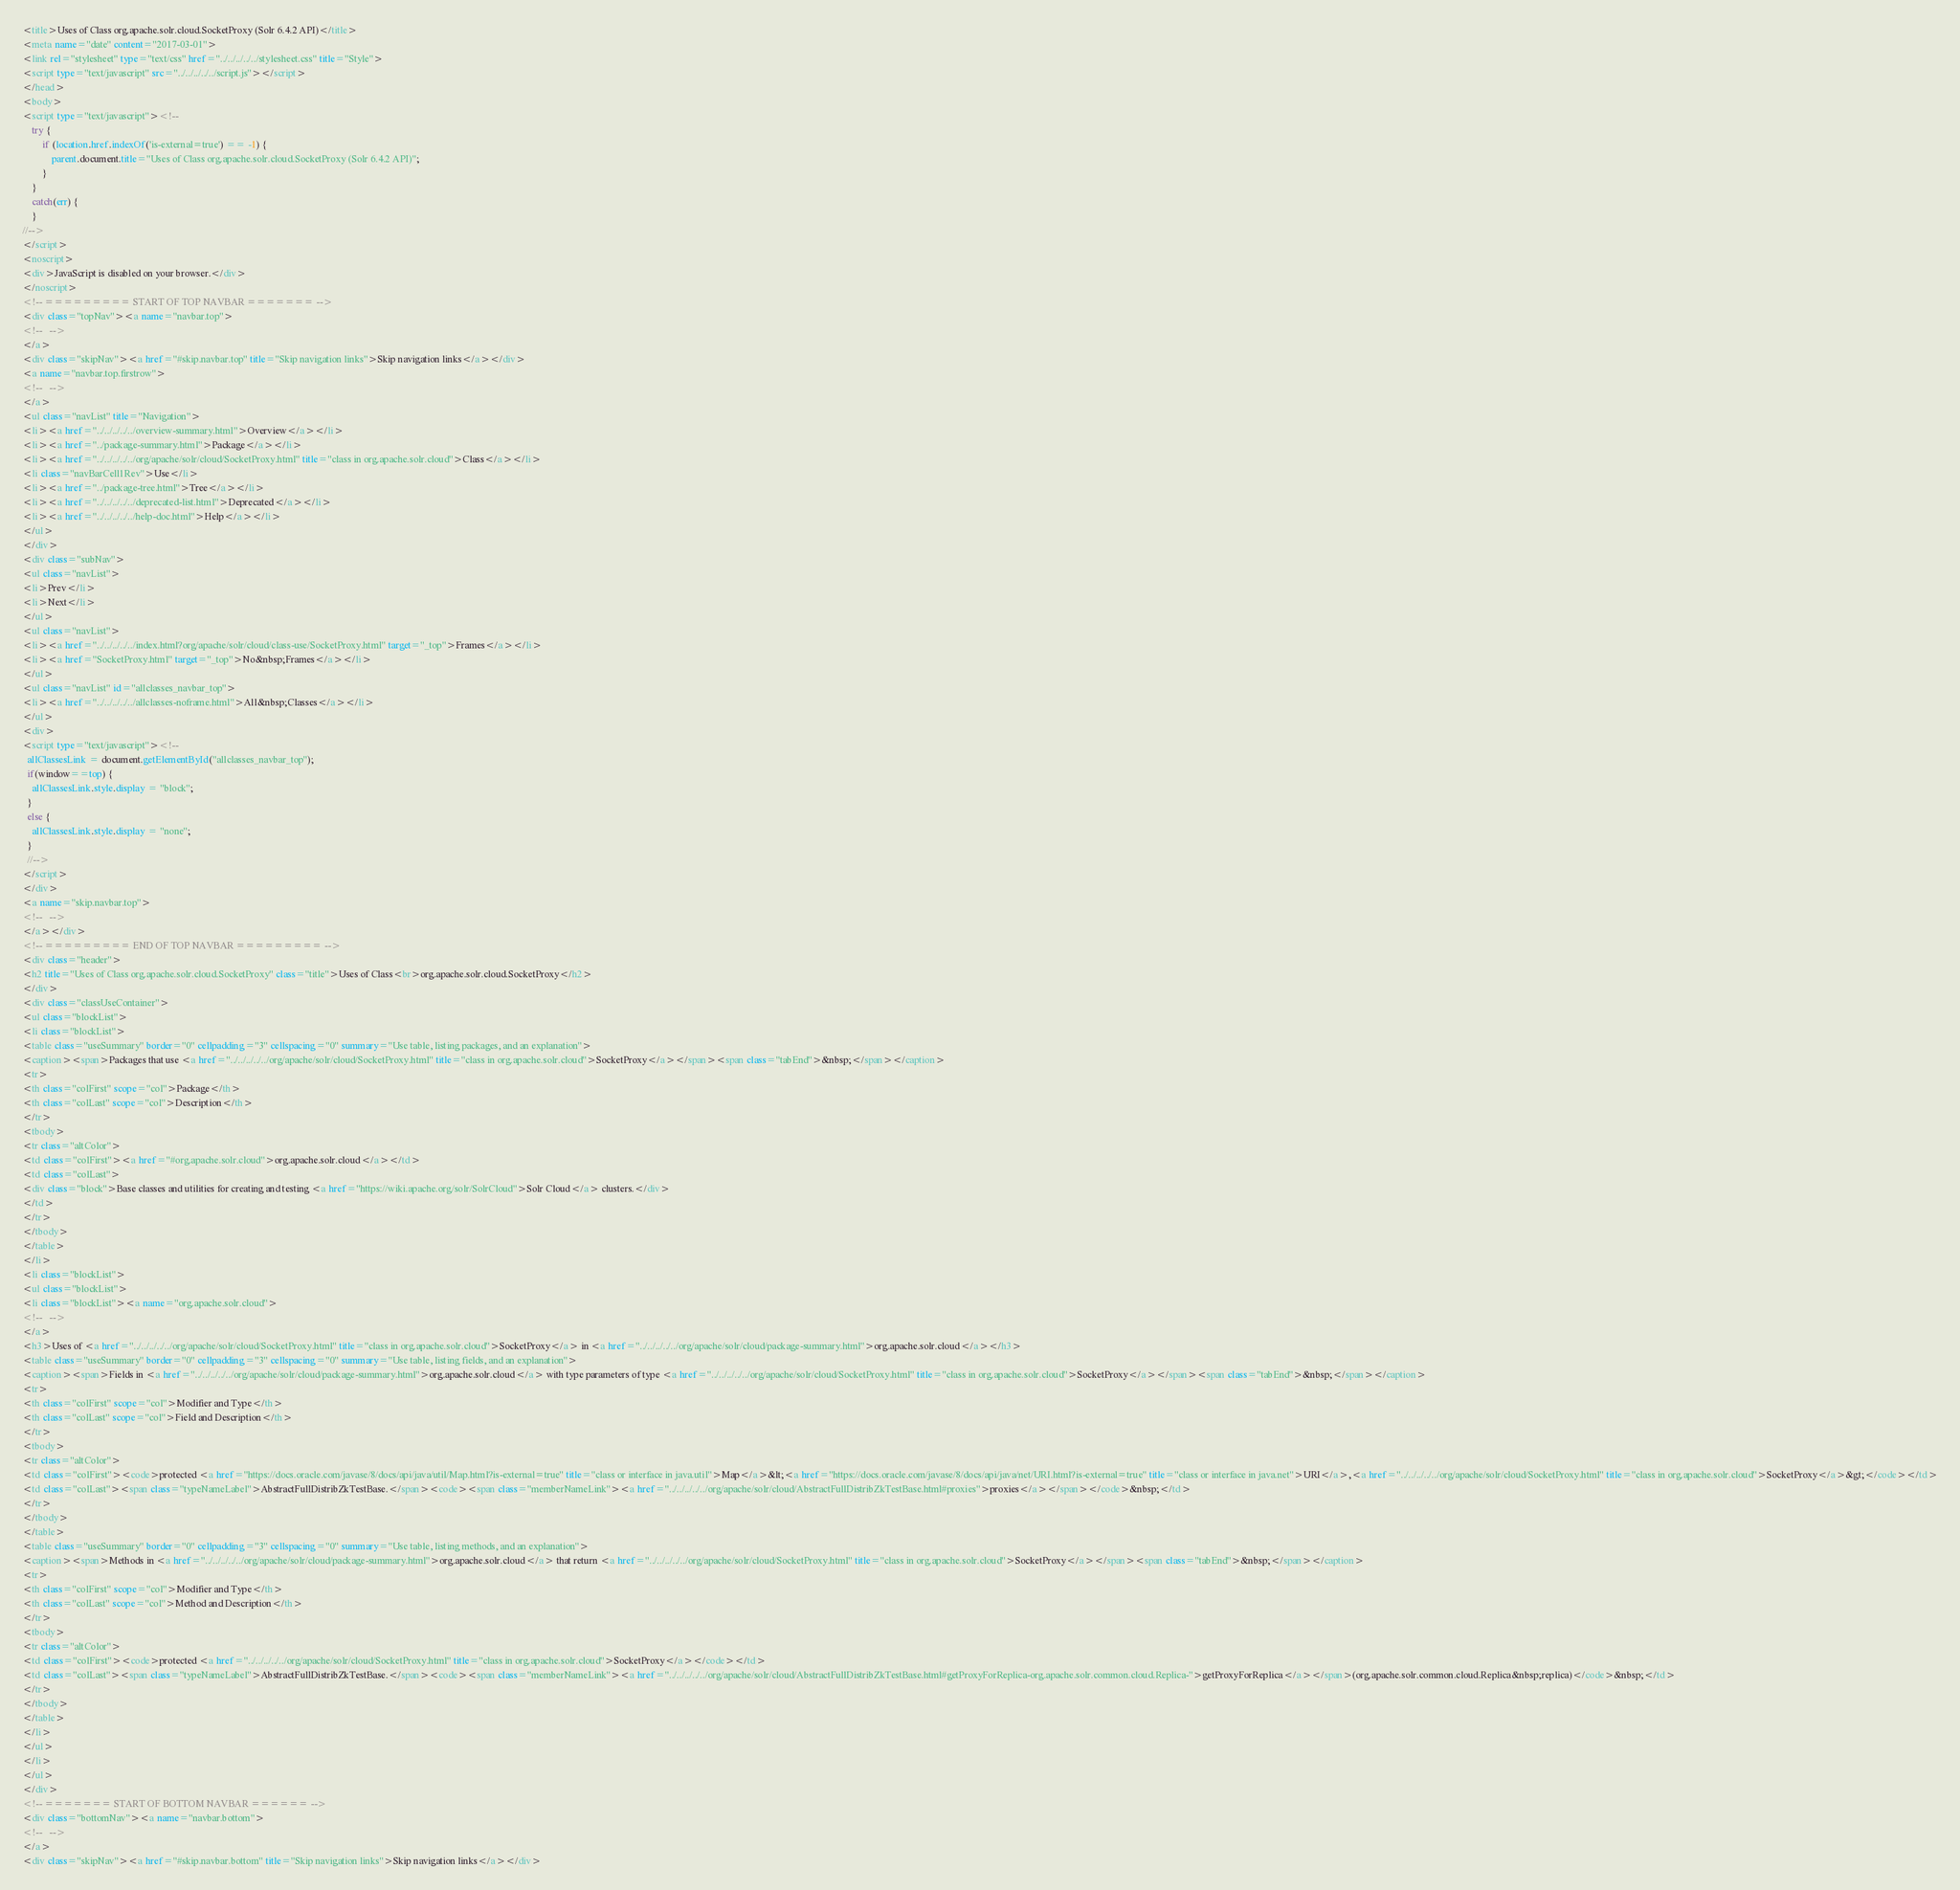Convert code to text. <code><loc_0><loc_0><loc_500><loc_500><_HTML_><title>Uses of Class org.apache.solr.cloud.SocketProxy (Solr 6.4.2 API)</title>
<meta name="date" content="2017-03-01">
<link rel="stylesheet" type="text/css" href="../../../../../stylesheet.css" title="Style">
<script type="text/javascript" src="../../../../../script.js"></script>
</head>
<body>
<script type="text/javascript"><!--
    try {
        if (location.href.indexOf('is-external=true') == -1) {
            parent.document.title="Uses of Class org.apache.solr.cloud.SocketProxy (Solr 6.4.2 API)";
        }
    }
    catch(err) {
    }
//-->
</script>
<noscript>
<div>JavaScript is disabled on your browser.</div>
</noscript>
<!-- ========= START OF TOP NAVBAR ======= -->
<div class="topNav"><a name="navbar.top">
<!--   -->
</a>
<div class="skipNav"><a href="#skip.navbar.top" title="Skip navigation links">Skip navigation links</a></div>
<a name="navbar.top.firstrow">
<!--   -->
</a>
<ul class="navList" title="Navigation">
<li><a href="../../../../../overview-summary.html">Overview</a></li>
<li><a href="../package-summary.html">Package</a></li>
<li><a href="../../../../../org/apache/solr/cloud/SocketProxy.html" title="class in org.apache.solr.cloud">Class</a></li>
<li class="navBarCell1Rev">Use</li>
<li><a href="../package-tree.html">Tree</a></li>
<li><a href="../../../../../deprecated-list.html">Deprecated</a></li>
<li><a href="../../../../../help-doc.html">Help</a></li>
</ul>
</div>
<div class="subNav">
<ul class="navList">
<li>Prev</li>
<li>Next</li>
</ul>
<ul class="navList">
<li><a href="../../../../../index.html?org/apache/solr/cloud/class-use/SocketProxy.html" target="_top">Frames</a></li>
<li><a href="SocketProxy.html" target="_top">No&nbsp;Frames</a></li>
</ul>
<ul class="navList" id="allclasses_navbar_top">
<li><a href="../../../../../allclasses-noframe.html">All&nbsp;Classes</a></li>
</ul>
<div>
<script type="text/javascript"><!--
  allClassesLink = document.getElementById("allclasses_navbar_top");
  if(window==top) {
    allClassesLink.style.display = "block";
  }
  else {
    allClassesLink.style.display = "none";
  }
  //-->
</script>
</div>
<a name="skip.navbar.top">
<!--   -->
</a></div>
<!-- ========= END OF TOP NAVBAR ========= -->
<div class="header">
<h2 title="Uses of Class org.apache.solr.cloud.SocketProxy" class="title">Uses of Class<br>org.apache.solr.cloud.SocketProxy</h2>
</div>
<div class="classUseContainer">
<ul class="blockList">
<li class="blockList">
<table class="useSummary" border="0" cellpadding="3" cellspacing="0" summary="Use table, listing packages, and an explanation">
<caption><span>Packages that use <a href="../../../../../org/apache/solr/cloud/SocketProxy.html" title="class in org.apache.solr.cloud">SocketProxy</a></span><span class="tabEnd">&nbsp;</span></caption>
<tr>
<th class="colFirst" scope="col">Package</th>
<th class="colLast" scope="col">Description</th>
</tr>
<tbody>
<tr class="altColor">
<td class="colFirst"><a href="#org.apache.solr.cloud">org.apache.solr.cloud</a></td>
<td class="colLast">
<div class="block">Base classes and utilities for creating and testing <a href="https://wiki.apache.org/solr/SolrCloud">Solr Cloud</a> clusters.</div>
</td>
</tr>
</tbody>
</table>
</li>
<li class="blockList">
<ul class="blockList">
<li class="blockList"><a name="org.apache.solr.cloud">
<!--   -->
</a>
<h3>Uses of <a href="../../../../../org/apache/solr/cloud/SocketProxy.html" title="class in org.apache.solr.cloud">SocketProxy</a> in <a href="../../../../../org/apache/solr/cloud/package-summary.html">org.apache.solr.cloud</a></h3>
<table class="useSummary" border="0" cellpadding="3" cellspacing="0" summary="Use table, listing fields, and an explanation">
<caption><span>Fields in <a href="../../../../../org/apache/solr/cloud/package-summary.html">org.apache.solr.cloud</a> with type parameters of type <a href="../../../../../org/apache/solr/cloud/SocketProxy.html" title="class in org.apache.solr.cloud">SocketProxy</a></span><span class="tabEnd">&nbsp;</span></caption>
<tr>
<th class="colFirst" scope="col">Modifier and Type</th>
<th class="colLast" scope="col">Field and Description</th>
</tr>
<tbody>
<tr class="altColor">
<td class="colFirst"><code>protected <a href="https://docs.oracle.com/javase/8/docs/api/java/util/Map.html?is-external=true" title="class or interface in java.util">Map</a>&lt;<a href="https://docs.oracle.com/javase/8/docs/api/java/net/URI.html?is-external=true" title="class or interface in java.net">URI</a>,<a href="../../../../../org/apache/solr/cloud/SocketProxy.html" title="class in org.apache.solr.cloud">SocketProxy</a>&gt;</code></td>
<td class="colLast"><span class="typeNameLabel">AbstractFullDistribZkTestBase.</span><code><span class="memberNameLink"><a href="../../../../../org/apache/solr/cloud/AbstractFullDistribZkTestBase.html#proxies">proxies</a></span></code>&nbsp;</td>
</tr>
</tbody>
</table>
<table class="useSummary" border="0" cellpadding="3" cellspacing="0" summary="Use table, listing methods, and an explanation">
<caption><span>Methods in <a href="../../../../../org/apache/solr/cloud/package-summary.html">org.apache.solr.cloud</a> that return <a href="../../../../../org/apache/solr/cloud/SocketProxy.html" title="class in org.apache.solr.cloud">SocketProxy</a></span><span class="tabEnd">&nbsp;</span></caption>
<tr>
<th class="colFirst" scope="col">Modifier and Type</th>
<th class="colLast" scope="col">Method and Description</th>
</tr>
<tbody>
<tr class="altColor">
<td class="colFirst"><code>protected <a href="../../../../../org/apache/solr/cloud/SocketProxy.html" title="class in org.apache.solr.cloud">SocketProxy</a></code></td>
<td class="colLast"><span class="typeNameLabel">AbstractFullDistribZkTestBase.</span><code><span class="memberNameLink"><a href="../../../../../org/apache/solr/cloud/AbstractFullDistribZkTestBase.html#getProxyForReplica-org.apache.solr.common.cloud.Replica-">getProxyForReplica</a></span>(org.apache.solr.common.cloud.Replica&nbsp;replica)</code>&nbsp;</td>
</tr>
</tbody>
</table>
</li>
</ul>
</li>
</ul>
</div>
<!-- ======= START OF BOTTOM NAVBAR ====== -->
<div class="bottomNav"><a name="navbar.bottom">
<!--   -->
</a>
<div class="skipNav"><a href="#skip.navbar.bottom" title="Skip navigation links">Skip navigation links</a></div></code> 